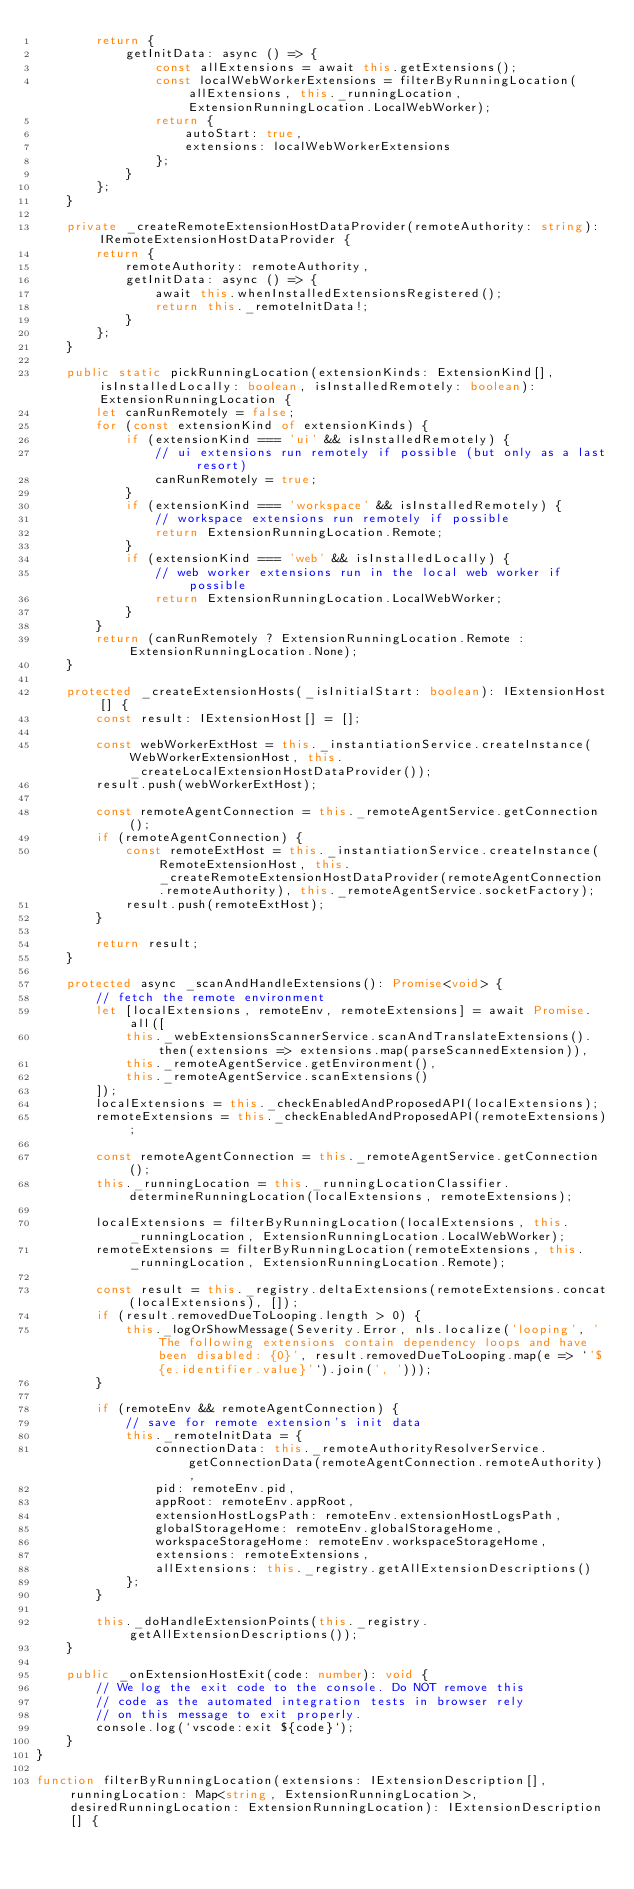Convert code to text. <code><loc_0><loc_0><loc_500><loc_500><_TypeScript_>		return {
			getInitData: async () => {
				const allExtensions = await this.getExtensions();
				const localWebWorkerExtensions = filterByRunningLocation(allExtensions, this._runningLocation, ExtensionRunningLocation.LocalWebWorker);
				return {
					autoStart: true,
					extensions: localWebWorkerExtensions
				};
			}
		};
	}

	private _createRemoteExtensionHostDataProvider(remoteAuthority: string): IRemoteExtensionHostDataProvider {
		return {
			remoteAuthority: remoteAuthority,
			getInitData: async () => {
				await this.whenInstalledExtensionsRegistered();
				return this._remoteInitData!;
			}
		};
	}

	public static pickRunningLocation(extensionKinds: ExtensionKind[], isInstalledLocally: boolean, isInstalledRemotely: boolean): ExtensionRunningLocation {
		let canRunRemotely = false;
		for (const extensionKind of extensionKinds) {
			if (extensionKind === 'ui' && isInstalledRemotely) {
				// ui extensions run remotely if possible (but only as a last resort)
				canRunRemotely = true;
			}
			if (extensionKind === 'workspace' && isInstalledRemotely) {
				// workspace extensions run remotely if possible
				return ExtensionRunningLocation.Remote;
			}
			if (extensionKind === 'web' && isInstalledLocally) {
				// web worker extensions run in the local web worker if possible
				return ExtensionRunningLocation.LocalWebWorker;
			}
		}
		return (canRunRemotely ? ExtensionRunningLocation.Remote : ExtensionRunningLocation.None);
	}

	protected _createExtensionHosts(_isInitialStart: boolean): IExtensionHost[] {
		const result: IExtensionHost[] = [];

		const webWorkerExtHost = this._instantiationService.createInstance(WebWorkerExtensionHost, this._createLocalExtensionHostDataProvider());
		result.push(webWorkerExtHost);

		const remoteAgentConnection = this._remoteAgentService.getConnection();
		if (remoteAgentConnection) {
			const remoteExtHost = this._instantiationService.createInstance(RemoteExtensionHost, this._createRemoteExtensionHostDataProvider(remoteAgentConnection.remoteAuthority), this._remoteAgentService.socketFactory);
			result.push(remoteExtHost);
		}

		return result;
	}

	protected async _scanAndHandleExtensions(): Promise<void> {
		// fetch the remote environment
		let [localExtensions, remoteEnv, remoteExtensions] = await Promise.all([
			this._webExtensionsScannerService.scanAndTranslateExtensions().then(extensions => extensions.map(parseScannedExtension)),
			this._remoteAgentService.getEnvironment(),
			this._remoteAgentService.scanExtensions()
		]);
		localExtensions = this._checkEnabledAndProposedAPI(localExtensions);
		remoteExtensions = this._checkEnabledAndProposedAPI(remoteExtensions);

		const remoteAgentConnection = this._remoteAgentService.getConnection();
		this._runningLocation = this._runningLocationClassifier.determineRunningLocation(localExtensions, remoteExtensions);

		localExtensions = filterByRunningLocation(localExtensions, this._runningLocation, ExtensionRunningLocation.LocalWebWorker);
		remoteExtensions = filterByRunningLocation(remoteExtensions, this._runningLocation, ExtensionRunningLocation.Remote);

		const result = this._registry.deltaExtensions(remoteExtensions.concat(localExtensions), []);
		if (result.removedDueToLooping.length > 0) {
			this._logOrShowMessage(Severity.Error, nls.localize('looping', 'The following extensions contain dependency loops and have been disabled: {0}', result.removedDueToLooping.map(e => `'${e.identifier.value}'`).join(', ')));
		}

		if (remoteEnv && remoteAgentConnection) {
			// save for remote extension's init data
			this._remoteInitData = {
				connectionData: this._remoteAuthorityResolverService.getConnectionData(remoteAgentConnection.remoteAuthority),
				pid: remoteEnv.pid,
				appRoot: remoteEnv.appRoot,
				extensionHostLogsPath: remoteEnv.extensionHostLogsPath,
				globalStorageHome: remoteEnv.globalStorageHome,
				workspaceStorageHome: remoteEnv.workspaceStorageHome,
				extensions: remoteExtensions,
				allExtensions: this._registry.getAllExtensionDescriptions()
			};
		}

		this._doHandleExtensionPoints(this._registry.getAllExtensionDescriptions());
	}

	public _onExtensionHostExit(code: number): void {
		// We log the exit code to the console. Do NOT remove this
		// code as the automated integration tests in browser rely
		// on this message to exit properly.
		console.log(`vscode:exit ${code}`);
	}
}

function filterByRunningLocation(extensions: IExtensionDescription[], runningLocation: Map<string, ExtensionRunningLocation>, desiredRunningLocation: ExtensionRunningLocation): IExtensionDescription[] {</code> 